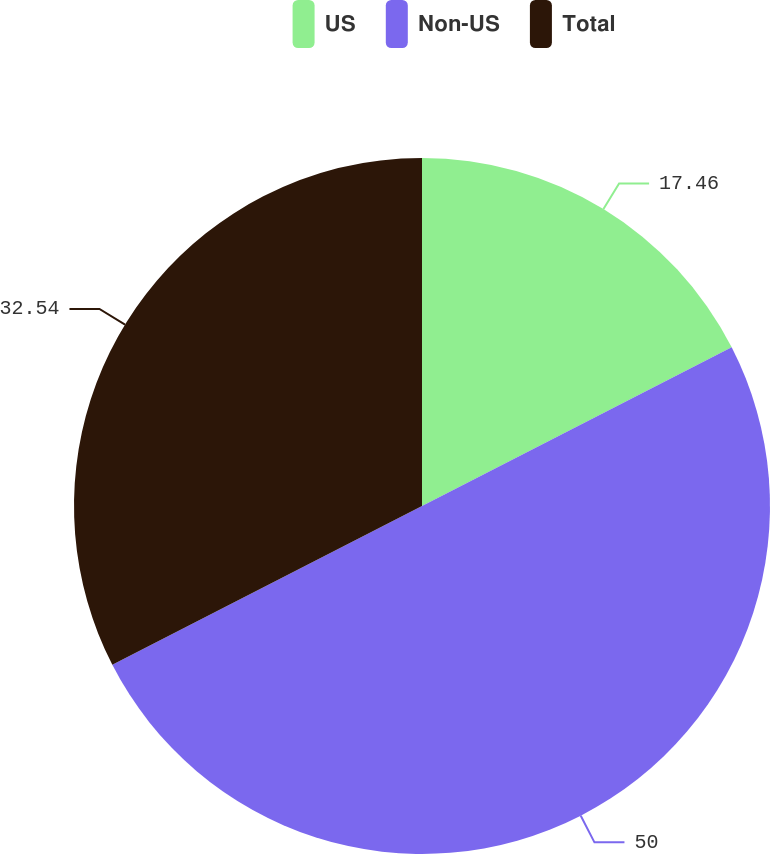Convert chart to OTSL. <chart><loc_0><loc_0><loc_500><loc_500><pie_chart><fcel>US<fcel>Non-US<fcel>Total<nl><fcel>17.46%<fcel>50.0%<fcel>32.54%<nl></chart> 